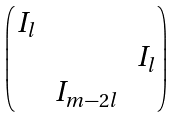Convert formula to latex. <formula><loc_0><loc_0><loc_500><loc_500>\begin{pmatrix} I _ { l } \\ & & I _ { l } \\ & I _ { m - 2 l } \end{pmatrix}</formula> 